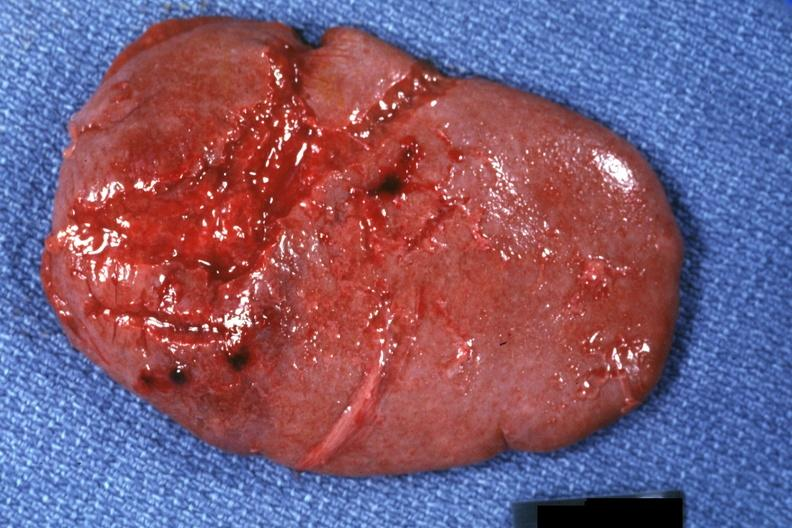s tumor present?
Answer the question using a single word or phrase. No 